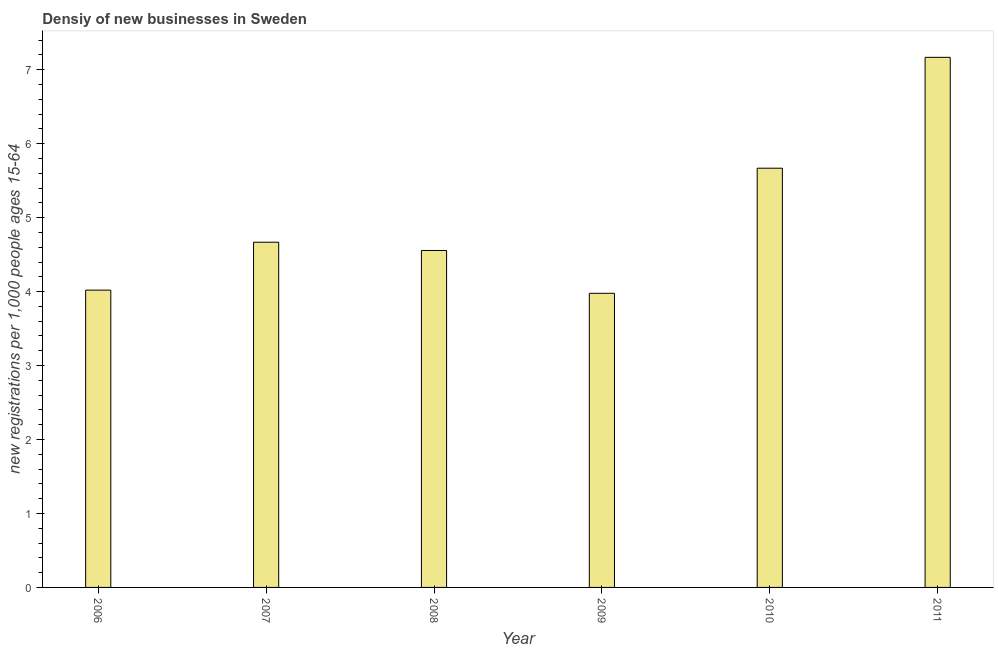Does the graph contain grids?
Give a very brief answer. No. What is the title of the graph?
Give a very brief answer. Densiy of new businesses in Sweden. What is the label or title of the X-axis?
Offer a very short reply. Year. What is the label or title of the Y-axis?
Offer a very short reply. New registrations per 1,0 people ages 15-64. What is the density of new business in 2011?
Your answer should be very brief. 7.17. Across all years, what is the maximum density of new business?
Provide a succinct answer. 7.17. Across all years, what is the minimum density of new business?
Your answer should be very brief. 3.98. In which year was the density of new business maximum?
Your answer should be very brief. 2011. What is the sum of the density of new business?
Offer a terse response. 30.06. What is the difference between the density of new business in 2006 and 2011?
Ensure brevity in your answer.  -3.15. What is the average density of new business per year?
Your answer should be very brief. 5.01. What is the median density of new business?
Offer a terse response. 4.61. What is the ratio of the density of new business in 2006 to that in 2008?
Give a very brief answer. 0.88. Is the difference between the density of new business in 2007 and 2011 greater than the difference between any two years?
Your answer should be very brief. No. What is the difference between the highest and the second highest density of new business?
Your response must be concise. 1.5. Is the sum of the density of new business in 2006 and 2010 greater than the maximum density of new business across all years?
Provide a short and direct response. Yes. What is the difference between the highest and the lowest density of new business?
Offer a terse response. 3.19. In how many years, is the density of new business greater than the average density of new business taken over all years?
Give a very brief answer. 2. Are all the bars in the graph horizontal?
Your answer should be compact. No. Are the values on the major ticks of Y-axis written in scientific E-notation?
Keep it short and to the point. No. What is the new registrations per 1,000 people ages 15-64 in 2006?
Keep it short and to the point. 4.02. What is the new registrations per 1,000 people ages 15-64 of 2007?
Your answer should be compact. 4.67. What is the new registrations per 1,000 people ages 15-64 of 2008?
Your response must be concise. 4.56. What is the new registrations per 1,000 people ages 15-64 in 2009?
Provide a short and direct response. 3.98. What is the new registrations per 1,000 people ages 15-64 in 2010?
Offer a terse response. 5.67. What is the new registrations per 1,000 people ages 15-64 in 2011?
Your answer should be compact. 7.17. What is the difference between the new registrations per 1,000 people ages 15-64 in 2006 and 2007?
Provide a succinct answer. -0.65. What is the difference between the new registrations per 1,000 people ages 15-64 in 2006 and 2008?
Your answer should be very brief. -0.54. What is the difference between the new registrations per 1,000 people ages 15-64 in 2006 and 2009?
Give a very brief answer. 0.04. What is the difference between the new registrations per 1,000 people ages 15-64 in 2006 and 2010?
Offer a terse response. -1.65. What is the difference between the new registrations per 1,000 people ages 15-64 in 2006 and 2011?
Your answer should be compact. -3.15. What is the difference between the new registrations per 1,000 people ages 15-64 in 2007 and 2008?
Your response must be concise. 0.11. What is the difference between the new registrations per 1,000 people ages 15-64 in 2007 and 2009?
Give a very brief answer. 0.69. What is the difference between the new registrations per 1,000 people ages 15-64 in 2007 and 2010?
Make the answer very short. -1. What is the difference between the new registrations per 1,000 people ages 15-64 in 2007 and 2011?
Your answer should be compact. -2.5. What is the difference between the new registrations per 1,000 people ages 15-64 in 2008 and 2009?
Your answer should be very brief. 0.58. What is the difference between the new registrations per 1,000 people ages 15-64 in 2008 and 2010?
Offer a very short reply. -1.11. What is the difference between the new registrations per 1,000 people ages 15-64 in 2008 and 2011?
Your answer should be compact. -2.61. What is the difference between the new registrations per 1,000 people ages 15-64 in 2009 and 2010?
Ensure brevity in your answer.  -1.69. What is the difference between the new registrations per 1,000 people ages 15-64 in 2009 and 2011?
Provide a succinct answer. -3.19. What is the difference between the new registrations per 1,000 people ages 15-64 in 2010 and 2011?
Offer a very short reply. -1.5. What is the ratio of the new registrations per 1,000 people ages 15-64 in 2006 to that in 2007?
Offer a very short reply. 0.86. What is the ratio of the new registrations per 1,000 people ages 15-64 in 2006 to that in 2008?
Provide a succinct answer. 0.88. What is the ratio of the new registrations per 1,000 people ages 15-64 in 2006 to that in 2010?
Provide a short and direct response. 0.71. What is the ratio of the new registrations per 1,000 people ages 15-64 in 2006 to that in 2011?
Your answer should be very brief. 0.56. What is the ratio of the new registrations per 1,000 people ages 15-64 in 2007 to that in 2008?
Offer a terse response. 1.02. What is the ratio of the new registrations per 1,000 people ages 15-64 in 2007 to that in 2009?
Your response must be concise. 1.17. What is the ratio of the new registrations per 1,000 people ages 15-64 in 2007 to that in 2010?
Ensure brevity in your answer.  0.82. What is the ratio of the new registrations per 1,000 people ages 15-64 in 2007 to that in 2011?
Ensure brevity in your answer.  0.65. What is the ratio of the new registrations per 1,000 people ages 15-64 in 2008 to that in 2009?
Offer a very short reply. 1.15. What is the ratio of the new registrations per 1,000 people ages 15-64 in 2008 to that in 2010?
Keep it short and to the point. 0.8. What is the ratio of the new registrations per 1,000 people ages 15-64 in 2008 to that in 2011?
Your answer should be compact. 0.64. What is the ratio of the new registrations per 1,000 people ages 15-64 in 2009 to that in 2010?
Offer a terse response. 0.7. What is the ratio of the new registrations per 1,000 people ages 15-64 in 2009 to that in 2011?
Ensure brevity in your answer.  0.56. What is the ratio of the new registrations per 1,000 people ages 15-64 in 2010 to that in 2011?
Offer a very short reply. 0.79. 